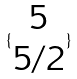<formula> <loc_0><loc_0><loc_500><loc_500>\{ \begin{matrix} 5 \\ 5 / 2 \end{matrix} \}</formula> 